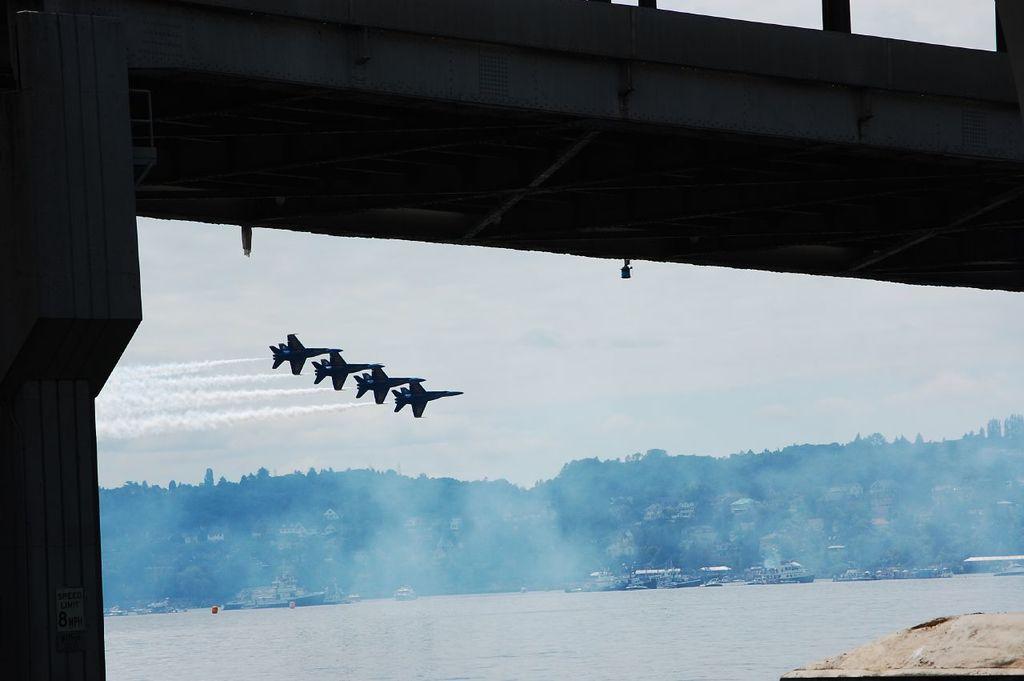Can you describe this image briefly? In this image there are a few fighter jets in the air, below them there is water, on the water there are a few boats, in the background of the image there are trees and mountains, at the top of the image there is a bridge with a pillar. 